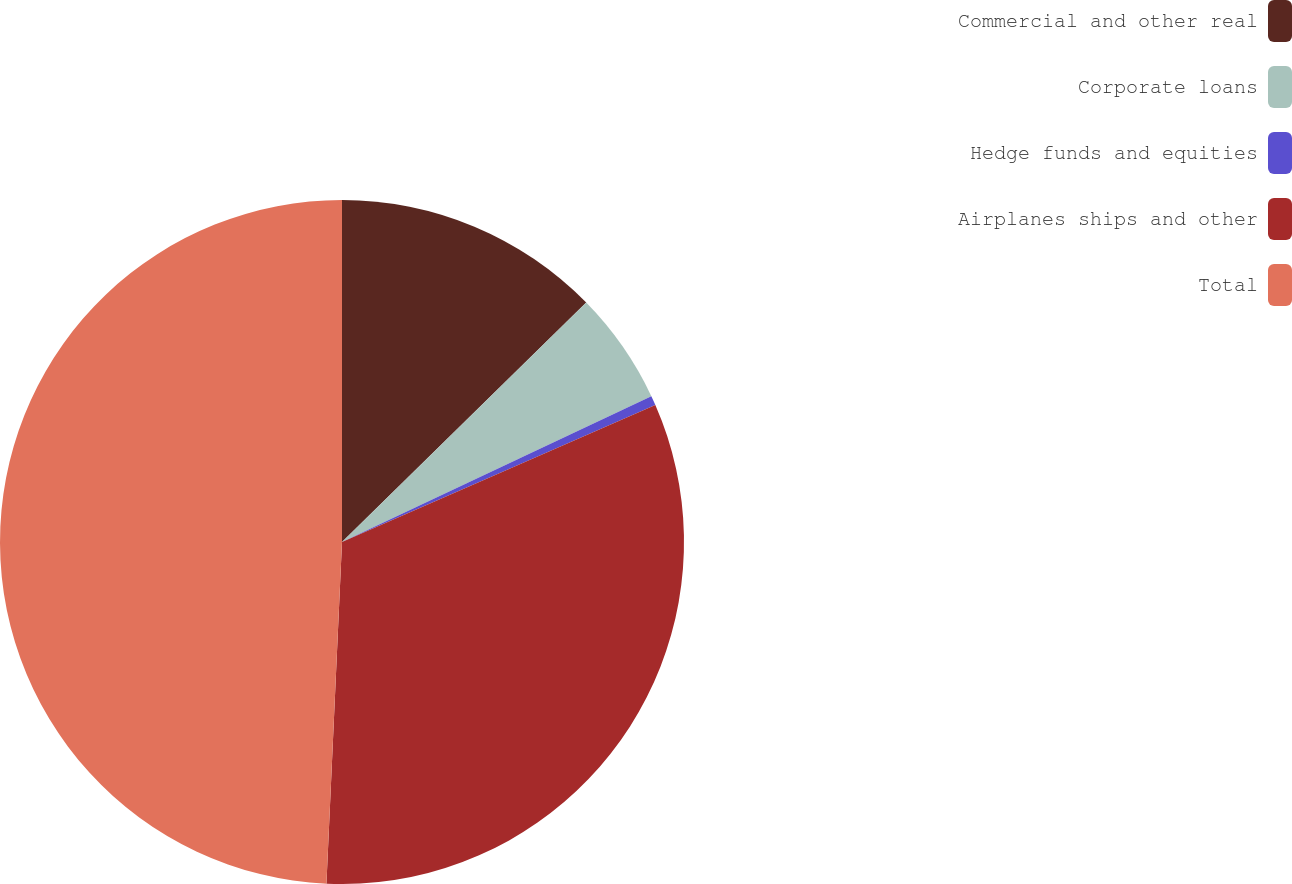Convert chart. <chart><loc_0><loc_0><loc_500><loc_500><pie_chart><fcel>Commercial and other real<fcel>Corporate loans<fcel>Hedge funds and equities<fcel>Airplanes ships and other<fcel>Total<nl><fcel>12.66%<fcel>5.33%<fcel>0.45%<fcel>32.29%<fcel>49.28%<nl></chart> 